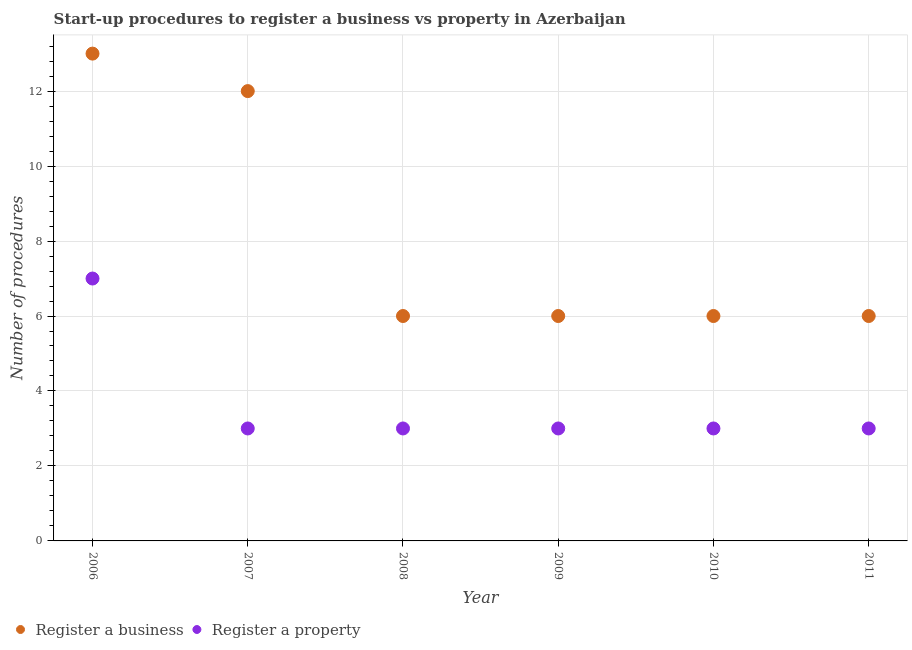Is the number of dotlines equal to the number of legend labels?
Offer a very short reply. Yes. What is the number of procedures to register a property in 2011?
Your answer should be compact. 3. Across all years, what is the maximum number of procedures to register a business?
Give a very brief answer. 13. Across all years, what is the minimum number of procedures to register a property?
Keep it short and to the point. 3. In which year was the number of procedures to register a business maximum?
Your answer should be compact. 2006. What is the total number of procedures to register a business in the graph?
Your answer should be compact. 49. What is the difference between the number of procedures to register a business in 2006 and that in 2009?
Your response must be concise. 7. What is the difference between the number of procedures to register a business in 2011 and the number of procedures to register a property in 2009?
Give a very brief answer. 3. What is the average number of procedures to register a property per year?
Keep it short and to the point. 3.67. In the year 2009, what is the difference between the number of procedures to register a property and number of procedures to register a business?
Your response must be concise. -3. Is the number of procedures to register a business in 2008 less than that in 2010?
Provide a succinct answer. No. What is the difference between the highest and the lowest number of procedures to register a property?
Your answer should be very brief. 4. In how many years, is the number of procedures to register a property greater than the average number of procedures to register a property taken over all years?
Keep it short and to the point. 1. Is the sum of the number of procedures to register a property in 2006 and 2010 greater than the maximum number of procedures to register a business across all years?
Your answer should be compact. No. Does the number of procedures to register a property monotonically increase over the years?
Your answer should be very brief. No. Is the number of procedures to register a property strictly less than the number of procedures to register a business over the years?
Keep it short and to the point. Yes. How many dotlines are there?
Your answer should be compact. 2. How many years are there in the graph?
Ensure brevity in your answer.  6. What is the difference between two consecutive major ticks on the Y-axis?
Make the answer very short. 2. Are the values on the major ticks of Y-axis written in scientific E-notation?
Offer a terse response. No. How many legend labels are there?
Your answer should be very brief. 2. How are the legend labels stacked?
Your response must be concise. Horizontal. What is the title of the graph?
Offer a very short reply. Start-up procedures to register a business vs property in Azerbaijan. Does "Short-term debt" appear as one of the legend labels in the graph?
Your answer should be very brief. No. What is the label or title of the X-axis?
Ensure brevity in your answer.  Year. What is the label or title of the Y-axis?
Make the answer very short. Number of procedures. What is the Number of procedures in Register a property in 2006?
Your answer should be very brief. 7. What is the Number of procedures of Register a business in 2007?
Offer a very short reply. 12. What is the Number of procedures of Register a property in 2007?
Your response must be concise. 3. What is the Number of procedures in Register a property in 2009?
Offer a very short reply. 3. What is the Number of procedures of Register a business in 2011?
Offer a terse response. 6. Across all years, what is the maximum Number of procedures of Register a property?
Make the answer very short. 7. Across all years, what is the minimum Number of procedures of Register a property?
Your answer should be very brief. 3. What is the difference between the Number of procedures in Register a property in 2006 and that in 2008?
Offer a terse response. 4. What is the difference between the Number of procedures of Register a property in 2006 and that in 2010?
Offer a terse response. 4. What is the difference between the Number of procedures of Register a business in 2006 and that in 2011?
Your answer should be very brief. 7. What is the difference between the Number of procedures in Register a property in 2006 and that in 2011?
Keep it short and to the point. 4. What is the difference between the Number of procedures in Register a business in 2007 and that in 2008?
Ensure brevity in your answer.  6. What is the difference between the Number of procedures of Register a property in 2007 and that in 2008?
Provide a succinct answer. 0. What is the difference between the Number of procedures of Register a business in 2007 and that in 2009?
Offer a terse response. 6. What is the difference between the Number of procedures of Register a business in 2007 and that in 2010?
Give a very brief answer. 6. What is the difference between the Number of procedures of Register a business in 2007 and that in 2011?
Your answer should be compact. 6. What is the difference between the Number of procedures of Register a property in 2007 and that in 2011?
Your answer should be very brief. 0. What is the difference between the Number of procedures of Register a business in 2008 and that in 2009?
Your answer should be compact. 0. What is the difference between the Number of procedures of Register a business in 2008 and that in 2010?
Keep it short and to the point. 0. What is the difference between the Number of procedures in Register a property in 2008 and that in 2010?
Offer a terse response. 0. What is the difference between the Number of procedures in Register a business in 2009 and that in 2010?
Your response must be concise. 0. What is the difference between the Number of procedures of Register a property in 2009 and that in 2010?
Offer a terse response. 0. What is the difference between the Number of procedures of Register a business in 2009 and that in 2011?
Give a very brief answer. 0. What is the difference between the Number of procedures in Register a business in 2010 and that in 2011?
Offer a terse response. 0. What is the difference between the Number of procedures in Register a business in 2006 and the Number of procedures in Register a property in 2007?
Ensure brevity in your answer.  10. What is the difference between the Number of procedures of Register a business in 2006 and the Number of procedures of Register a property in 2008?
Keep it short and to the point. 10. What is the difference between the Number of procedures in Register a business in 2006 and the Number of procedures in Register a property in 2011?
Ensure brevity in your answer.  10. What is the difference between the Number of procedures in Register a business in 2007 and the Number of procedures in Register a property in 2008?
Keep it short and to the point. 9. What is the difference between the Number of procedures of Register a business in 2007 and the Number of procedures of Register a property in 2010?
Ensure brevity in your answer.  9. What is the difference between the Number of procedures in Register a business in 2007 and the Number of procedures in Register a property in 2011?
Your answer should be very brief. 9. What is the difference between the Number of procedures of Register a business in 2008 and the Number of procedures of Register a property in 2009?
Make the answer very short. 3. What is the difference between the Number of procedures in Register a business in 2008 and the Number of procedures in Register a property in 2011?
Keep it short and to the point. 3. What is the difference between the Number of procedures of Register a business in 2009 and the Number of procedures of Register a property in 2010?
Ensure brevity in your answer.  3. What is the difference between the Number of procedures of Register a business in 2009 and the Number of procedures of Register a property in 2011?
Your answer should be very brief. 3. What is the difference between the Number of procedures of Register a business in 2010 and the Number of procedures of Register a property in 2011?
Provide a short and direct response. 3. What is the average Number of procedures in Register a business per year?
Make the answer very short. 8.17. What is the average Number of procedures in Register a property per year?
Provide a succinct answer. 3.67. In the year 2008, what is the difference between the Number of procedures in Register a business and Number of procedures in Register a property?
Your answer should be very brief. 3. In the year 2009, what is the difference between the Number of procedures of Register a business and Number of procedures of Register a property?
Your answer should be compact. 3. In the year 2010, what is the difference between the Number of procedures of Register a business and Number of procedures of Register a property?
Ensure brevity in your answer.  3. In the year 2011, what is the difference between the Number of procedures of Register a business and Number of procedures of Register a property?
Give a very brief answer. 3. What is the ratio of the Number of procedures of Register a property in 2006 to that in 2007?
Your response must be concise. 2.33. What is the ratio of the Number of procedures of Register a business in 2006 to that in 2008?
Your answer should be very brief. 2.17. What is the ratio of the Number of procedures of Register a property in 2006 to that in 2008?
Keep it short and to the point. 2.33. What is the ratio of the Number of procedures of Register a business in 2006 to that in 2009?
Offer a very short reply. 2.17. What is the ratio of the Number of procedures of Register a property in 2006 to that in 2009?
Offer a terse response. 2.33. What is the ratio of the Number of procedures of Register a business in 2006 to that in 2010?
Keep it short and to the point. 2.17. What is the ratio of the Number of procedures in Register a property in 2006 to that in 2010?
Provide a succinct answer. 2.33. What is the ratio of the Number of procedures of Register a business in 2006 to that in 2011?
Give a very brief answer. 2.17. What is the ratio of the Number of procedures in Register a property in 2006 to that in 2011?
Provide a short and direct response. 2.33. What is the ratio of the Number of procedures of Register a business in 2007 to that in 2009?
Your answer should be compact. 2. What is the ratio of the Number of procedures in Register a property in 2007 to that in 2009?
Offer a terse response. 1. What is the ratio of the Number of procedures in Register a business in 2007 to that in 2010?
Your response must be concise. 2. What is the ratio of the Number of procedures of Register a property in 2007 to that in 2011?
Your answer should be very brief. 1. What is the ratio of the Number of procedures of Register a business in 2008 to that in 2009?
Offer a terse response. 1. What is the ratio of the Number of procedures of Register a property in 2008 to that in 2009?
Your answer should be very brief. 1. What is the ratio of the Number of procedures in Register a business in 2008 to that in 2010?
Your answer should be compact. 1. What is the ratio of the Number of procedures of Register a business in 2009 to that in 2010?
Keep it short and to the point. 1. What is the ratio of the Number of procedures in Register a property in 2010 to that in 2011?
Offer a terse response. 1. What is the difference between the highest and the second highest Number of procedures of Register a business?
Offer a terse response. 1. What is the difference between the highest and the lowest Number of procedures of Register a business?
Give a very brief answer. 7. What is the difference between the highest and the lowest Number of procedures in Register a property?
Keep it short and to the point. 4. 